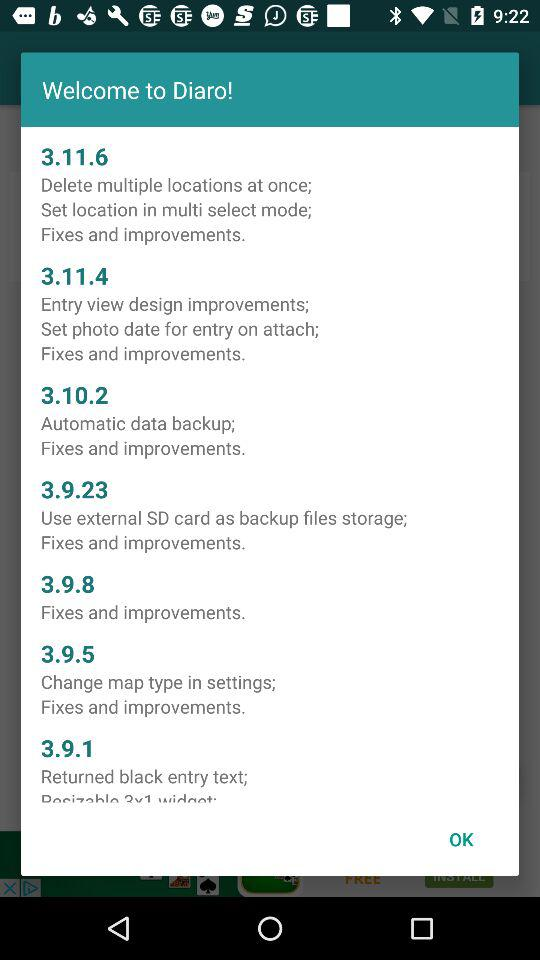What is the application name? The application name is "Diaro". 